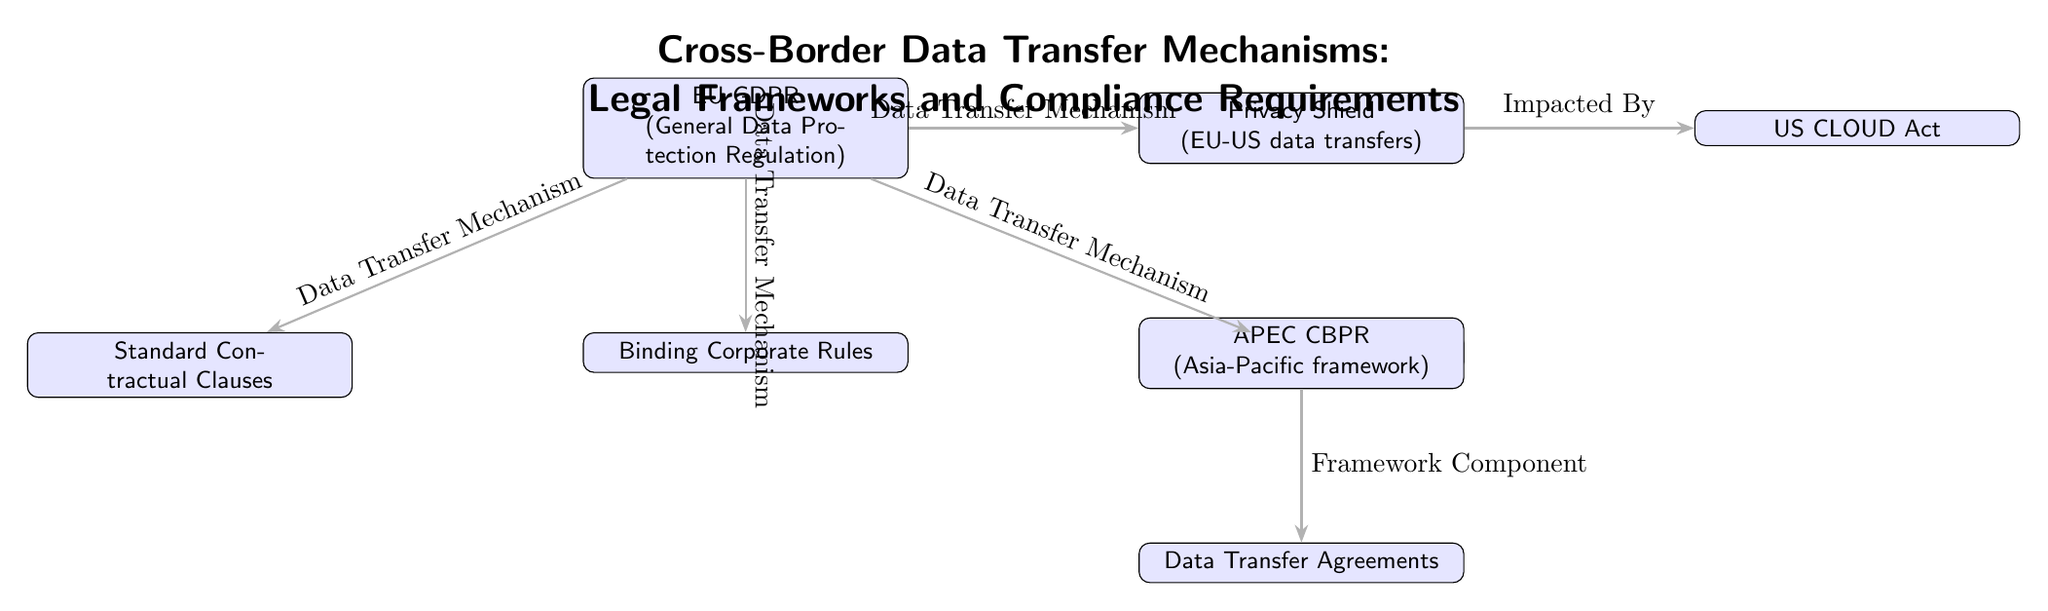What are the three main data transfer mechanisms under the EU GDPR? The diagram lists three mechanisms: Standard Contractual Clauses, Binding Corporate Rules, and Adequacy Decisions, all connected under the EU GDPR node.
Answer: Standard Contractual Clauses, Binding Corporate Rules, Adequacy Decisions Which mechanism is impacted by the Privacy Shield? The arrow from Privacy Shield to US CLOUD Act indicates a relationship where the US CLOUD Act is impacted by the Privacy Shield.
Answer: US CLOUD Act How many data transfer mechanisms are represented in the diagram? By counting the nodes connected to the EU GDPR, there are a total of four mechanisms: SCC, BCR, AD, and PS.
Answer: Four What type of agreement is a component of the APEC framework? The diagram connects APEC CBPR to Data Transfer Agreements, labeling this relationship as a "Framework Component."
Answer: Data Transfer Agreements Which data transfer mechanism is specifically indicated for EU-US data transfers? The diagram clearly identifies the Privacy Shield as the mechanism designated for EU-US data transfers, represented next to that label.
Answer: Privacy Shield How does the US CLOUD Act relate to the Privacy Shield? The arrow labeled "Impacted By" from Privacy Shield to US CLOUD Act indicates that the latter is affected by the former, showing a relational dependence.
Answer: Impacted By What do SCC, BCR, and AD have in common? All three mechanisms are categorized under the EU GDPR, connected directly to this central node, showing they belong to the same regulatory framework.
Answer: Associated with EU GDPR What is the relation between APEC and Data Transfer Agreements? The diagram uses a labeled arrow to indicate that Data Transfer Agreements are a component of the APEC CBPR framework, demonstrating a structural relationship.
Answer: Framework Component What is the title of the diagram? The title at the top of the diagram reads “Cross-Border Data Transfer Mechanisms: Legal Frameworks and Compliance Requirements.”
Answer: Cross-Border Data Transfer Mechanisms: Legal Frameworks and Compliance Requirements 